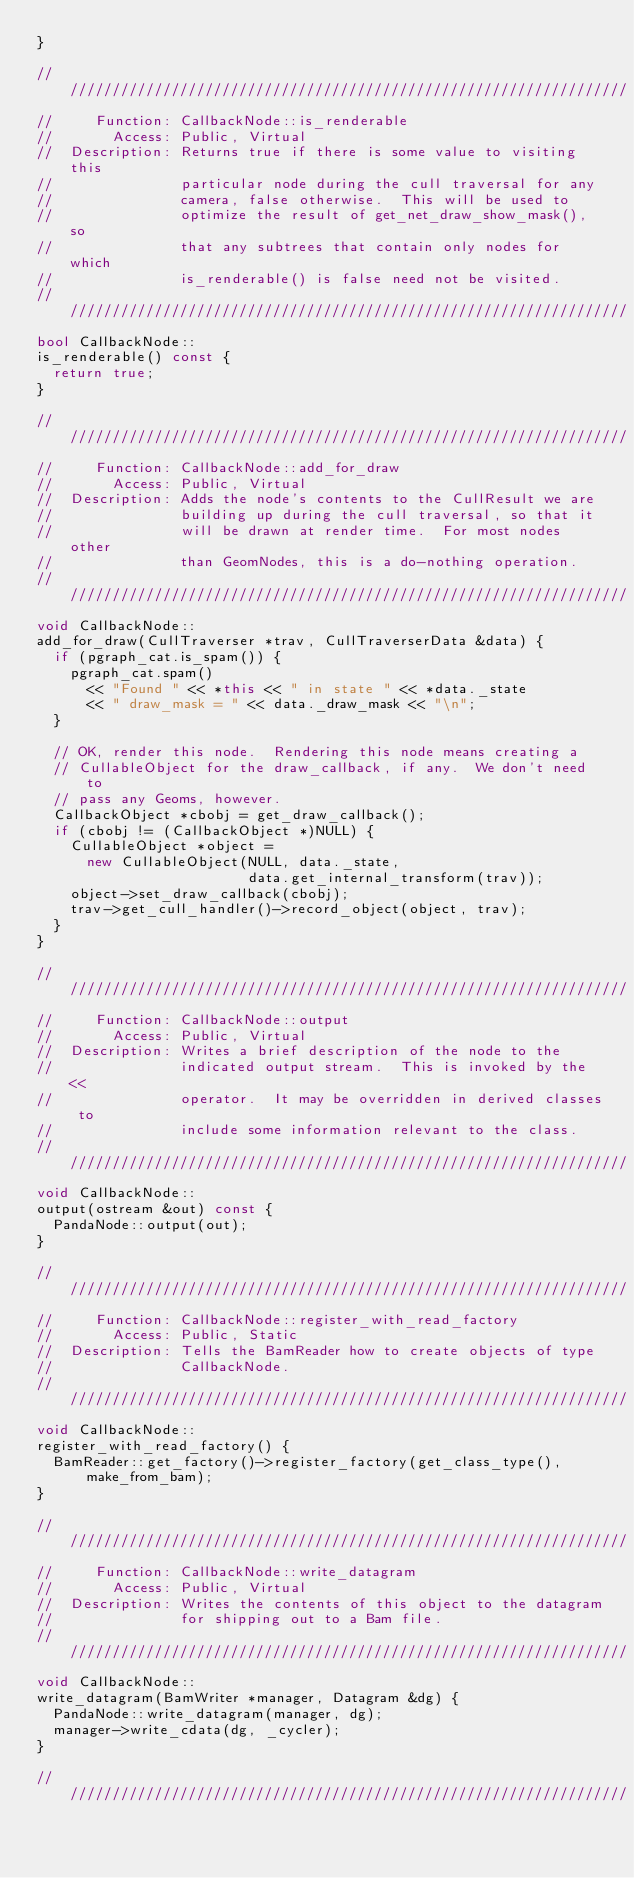Convert code to text. <code><loc_0><loc_0><loc_500><loc_500><_C++_>}

////////////////////////////////////////////////////////////////////
//     Function: CallbackNode::is_renderable
//       Access: Public, Virtual
//  Description: Returns true if there is some value to visiting this
//               particular node during the cull traversal for any
//               camera, false otherwise.  This will be used to
//               optimize the result of get_net_draw_show_mask(), so
//               that any subtrees that contain only nodes for which
//               is_renderable() is false need not be visited.
////////////////////////////////////////////////////////////////////
bool CallbackNode::
is_renderable() const {
  return true;
}

////////////////////////////////////////////////////////////////////
//     Function: CallbackNode::add_for_draw
//       Access: Public, Virtual
//  Description: Adds the node's contents to the CullResult we are
//               building up during the cull traversal, so that it
//               will be drawn at render time.  For most nodes other
//               than GeomNodes, this is a do-nothing operation.
////////////////////////////////////////////////////////////////////
void CallbackNode::
add_for_draw(CullTraverser *trav, CullTraverserData &data) {
  if (pgraph_cat.is_spam()) {
    pgraph_cat.spam()
      << "Found " << *this << " in state " << *data._state
      << " draw_mask = " << data._draw_mask << "\n";
  }

  // OK, render this node.  Rendering this node means creating a
  // CullableObject for the draw_callback, if any.  We don't need to
  // pass any Geoms, however.
  CallbackObject *cbobj = get_draw_callback();
  if (cbobj != (CallbackObject *)NULL) {
    CullableObject *object =
      new CullableObject(NULL, data._state,
                         data.get_internal_transform(trav));
    object->set_draw_callback(cbobj);
    trav->get_cull_handler()->record_object(object, trav);
  }
}

////////////////////////////////////////////////////////////////////
//     Function: CallbackNode::output
//       Access: Public, Virtual
//  Description: Writes a brief description of the node to the
//               indicated output stream.  This is invoked by the <<
//               operator.  It may be overridden in derived classes to
//               include some information relevant to the class.
////////////////////////////////////////////////////////////////////
void CallbackNode::
output(ostream &out) const {
  PandaNode::output(out);
}

////////////////////////////////////////////////////////////////////
//     Function: CallbackNode::register_with_read_factory
//       Access: Public, Static
//  Description: Tells the BamReader how to create objects of type
//               CallbackNode.
////////////////////////////////////////////////////////////////////
void CallbackNode::
register_with_read_factory() {
  BamReader::get_factory()->register_factory(get_class_type(), make_from_bam);
}

////////////////////////////////////////////////////////////////////
//     Function: CallbackNode::write_datagram
//       Access: Public, Virtual
//  Description: Writes the contents of this object to the datagram
//               for shipping out to a Bam file.
////////////////////////////////////////////////////////////////////
void CallbackNode::
write_datagram(BamWriter *manager, Datagram &dg) {
  PandaNode::write_datagram(manager, dg);
  manager->write_cdata(dg, _cycler);
}

////////////////////////////////////////////////////////////////////</code> 